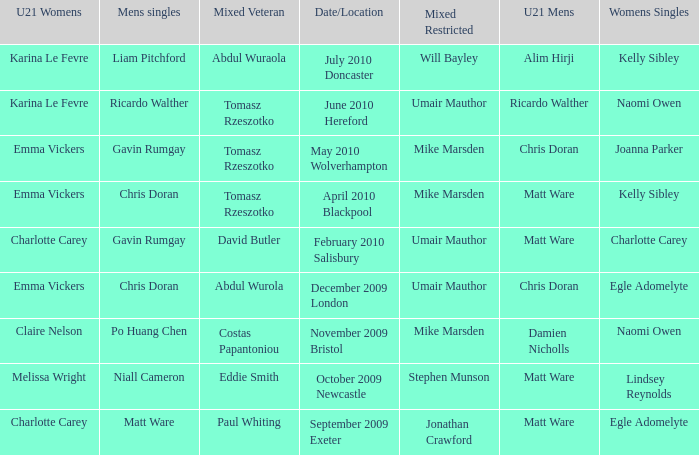When Naomi Owen won the Womens Singles and Ricardo Walther won the Mens Singles, who won the mixed veteran? Tomasz Rzeszotko. 